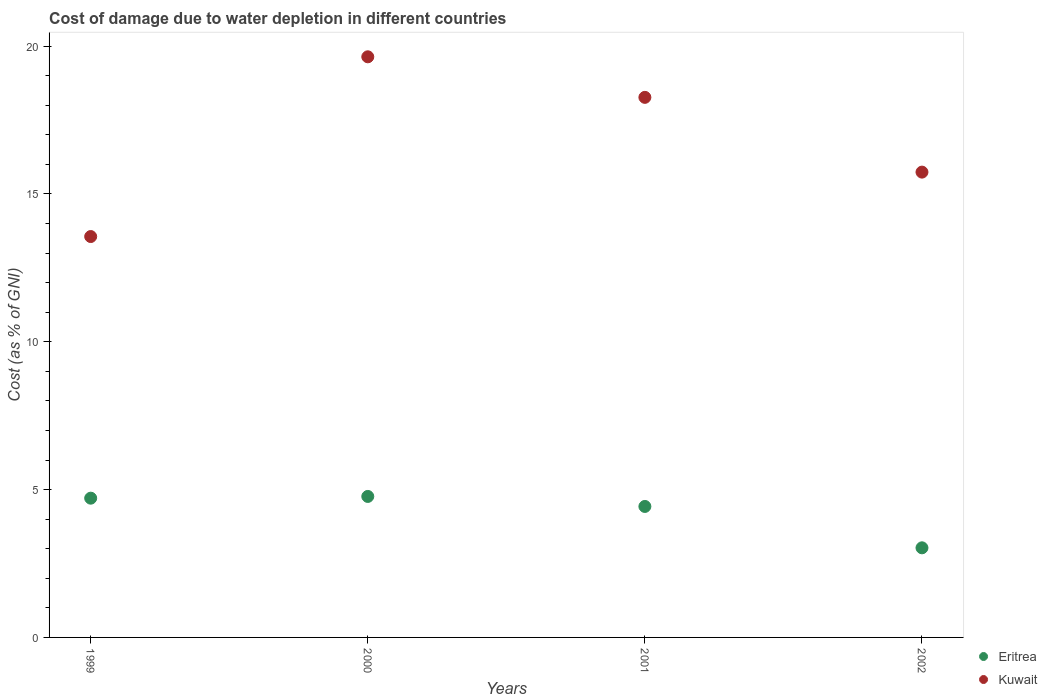What is the cost of damage caused due to water depletion in Eritrea in 2001?
Give a very brief answer. 4.43. Across all years, what is the maximum cost of damage caused due to water depletion in Eritrea?
Offer a very short reply. 4.77. Across all years, what is the minimum cost of damage caused due to water depletion in Kuwait?
Offer a terse response. 13.56. What is the total cost of damage caused due to water depletion in Eritrea in the graph?
Provide a short and direct response. 16.94. What is the difference between the cost of damage caused due to water depletion in Kuwait in 2000 and that in 2001?
Offer a very short reply. 1.37. What is the difference between the cost of damage caused due to water depletion in Kuwait in 2002 and the cost of damage caused due to water depletion in Eritrea in 1999?
Offer a very short reply. 11.03. What is the average cost of damage caused due to water depletion in Eritrea per year?
Keep it short and to the point. 4.23. In the year 2001, what is the difference between the cost of damage caused due to water depletion in Kuwait and cost of damage caused due to water depletion in Eritrea?
Your answer should be compact. 13.83. What is the ratio of the cost of damage caused due to water depletion in Eritrea in 1999 to that in 2001?
Offer a very short reply. 1.06. Is the difference between the cost of damage caused due to water depletion in Kuwait in 1999 and 2001 greater than the difference between the cost of damage caused due to water depletion in Eritrea in 1999 and 2001?
Keep it short and to the point. No. What is the difference between the highest and the second highest cost of damage caused due to water depletion in Kuwait?
Offer a terse response. 1.37. What is the difference between the highest and the lowest cost of damage caused due to water depletion in Eritrea?
Provide a succinct answer. 1.74. In how many years, is the cost of damage caused due to water depletion in Eritrea greater than the average cost of damage caused due to water depletion in Eritrea taken over all years?
Ensure brevity in your answer.  3. Is the sum of the cost of damage caused due to water depletion in Eritrea in 2000 and 2001 greater than the maximum cost of damage caused due to water depletion in Kuwait across all years?
Your answer should be very brief. No. Is the cost of damage caused due to water depletion in Eritrea strictly greater than the cost of damage caused due to water depletion in Kuwait over the years?
Your response must be concise. No. How many dotlines are there?
Give a very brief answer. 2. How many years are there in the graph?
Give a very brief answer. 4. What is the difference between two consecutive major ticks on the Y-axis?
Offer a very short reply. 5. Does the graph contain any zero values?
Ensure brevity in your answer.  No. What is the title of the graph?
Your answer should be very brief. Cost of damage due to water depletion in different countries. Does "Lower middle income" appear as one of the legend labels in the graph?
Provide a short and direct response. No. What is the label or title of the Y-axis?
Your response must be concise. Cost (as % of GNI). What is the Cost (as % of GNI) of Eritrea in 1999?
Keep it short and to the point. 4.71. What is the Cost (as % of GNI) of Kuwait in 1999?
Give a very brief answer. 13.56. What is the Cost (as % of GNI) of Eritrea in 2000?
Your answer should be very brief. 4.77. What is the Cost (as % of GNI) in Kuwait in 2000?
Give a very brief answer. 19.64. What is the Cost (as % of GNI) of Eritrea in 2001?
Your answer should be compact. 4.43. What is the Cost (as % of GNI) in Kuwait in 2001?
Ensure brevity in your answer.  18.26. What is the Cost (as % of GNI) in Eritrea in 2002?
Offer a very short reply. 3.03. What is the Cost (as % of GNI) of Kuwait in 2002?
Give a very brief answer. 15.74. Across all years, what is the maximum Cost (as % of GNI) of Eritrea?
Provide a short and direct response. 4.77. Across all years, what is the maximum Cost (as % of GNI) in Kuwait?
Your response must be concise. 19.64. Across all years, what is the minimum Cost (as % of GNI) of Eritrea?
Your answer should be very brief. 3.03. Across all years, what is the minimum Cost (as % of GNI) in Kuwait?
Your answer should be very brief. 13.56. What is the total Cost (as % of GNI) of Eritrea in the graph?
Give a very brief answer. 16.94. What is the total Cost (as % of GNI) in Kuwait in the graph?
Provide a short and direct response. 67.19. What is the difference between the Cost (as % of GNI) of Eritrea in 1999 and that in 2000?
Your answer should be compact. -0.06. What is the difference between the Cost (as % of GNI) of Kuwait in 1999 and that in 2000?
Offer a terse response. -6.08. What is the difference between the Cost (as % of GNI) in Eritrea in 1999 and that in 2001?
Give a very brief answer. 0.28. What is the difference between the Cost (as % of GNI) in Kuwait in 1999 and that in 2001?
Your answer should be compact. -4.71. What is the difference between the Cost (as % of GNI) of Eritrea in 1999 and that in 2002?
Your answer should be very brief. 1.68. What is the difference between the Cost (as % of GNI) of Kuwait in 1999 and that in 2002?
Your response must be concise. -2.18. What is the difference between the Cost (as % of GNI) of Eritrea in 2000 and that in 2001?
Provide a short and direct response. 0.34. What is the difference between the Cost (as % of GNI) of Kuwait in 2000 and that in 2001?
Offer a terse response. 1.37. What is the difference between the Cost (as % of GNI) of Eritrea in 2000 and that in 2002?
Offer a terse response. 1.74. What is the difference between the Cost (as % of GNI) of Kuwait in 2000 and that in 2002?
Make the answer very short. 3.9. What is the difference between the Cost (as % of GNI) of Eritrea in 2001 and that in 2002?
Your answer should be very brief. 1.4. What is the difference between the Cost (as % of GNI) of Kuwait in 2001 and that in 2002?
Provide a succinct answer. 2.53. What is the difference between the Cost (as % of GNI) of Eritrea in 1999 and the Cost (as % of GNI) of Kuwait in 2000?
Offer a terse response. -14.93. What is the difference between the Cost (as % of GNI) of Eritrea in 1999 and the Cost (as % of GNI) of Kuwait in 2001?
Your answer should be compact. -13.55. What is the difference between the Cost (as % of GNI) of Eritrea in 1999 and the Cost (as % of GNI) of Kuwait in 2002?
Make the answer very short. -11.03. What is the difference between the Cost (as % of GNI) of Eritrea in 2000 and the Cost (as % of GNI) of Kuwait in 2001?
Provide a short and direct response. -13.5. What is the difference between the Cost (as % of GNI) of Eritrea in 2000 and the Cost (as % of GNI) of Kuwait in 2002?
Your answer should be very brief. -10.97. What is the difference between the Cost (as % of GNI) in Eritrea in 2001 and the Cost (as % of GNI) in Kuwait in 2002?
Provide a succinct answer. -11.31. What is the average Cost (as % of GNI) in Eritrea per year?
Provide a succinct answer. 4.23. What is the average Cost (as % of GNI) in Kuwait per year?
Keep it short and to the point. 16.8. In the year 1999, what is the difference between the Cost (as % of GNI) of Eritrea and Cost (as % of GNI) of Kuwait?
Ensure brevity in your answer.  -8.85. In the year 2000, what is the difference between the Cost (as % of GNI) of Eritrea and Cost (as % of GNI) of Kuwait?
Provide a short and direct response. -14.87. In the year 2001, what is the difference between the Cost (as % of GNI) of Eritrea and Cost (as % of GNI) of Kuwait?
Make the answer very short. -13.83. In the year 2002, what is the difference between the Cost (as % of GNI) of Eritrea and Cost (as % of GNI) of Kuwait?
Your answer should be compact. -12.71. What is the ratio of the Cost (as % of GNI) in Eritrea in 1999 to that in 2000?
Keep it short and to the point. 0.99. What is the ratio of the Cost (as % of GNI) of Kuwait in 1999 to that in 2000?
Make the answer very short. 0.69. What is the ratio of the Cost (as % of GNI) in Eritrea in 1999 to that in 2001?
Offer a very short reply. 1.06. What is the ratio of the Cost (as % of GNI) of Kuwait in 1999 to that in 2001?
Provide a short and direct response. 0.74. What is the ratio of the Cost (as % of GNI) of Eritrea in 1999 to that in 2002?
Provide a succinct answer. 1.55. What is the ratio of the Cost (as % of GNI) in Kuwait in 1999 to that in 2002?
Your answer should be compact. 0.86. What is the ratio of the Cost (as % of GNI) of Eritrea in 2000 to that in 2001?
Ensure brevity in your answer.  1.08. What is the ratio of the Cost (as % of GNI) of Kuwait in 2000 to that in 2001?
Keep it short and to the point. 1.08. What is the ratio of the Cost (as % of GNI) of Eritrea in 2000 to that in 2002?
Provide a succinct answer. 1.57. What is the ratio of the Cost (as % of GNI) in Kuwait in 2000 to that in 2002?
Make the answer very short. 1.25. What is the ratio of the Cost (as % of GNI) in Eritrea in 2001 to that in 2002?
Keep it short and to the point. 1.46. What is the ratio of the Cost (as % of GNI) of Kuwait in 2001 to that in 2002?
Offer a terse response. 1.16. What is the difference between the highest and the second highest Cost (as % of GNI) of Eritrea?
Give a very brief answer. 0.06. What is the difference between the highest and the second highest Cost (as % of GNI) of Kuwait?
Give a very brief answer. 1.37. What is the difference between the highest and the lowest Cost (as % of GNI) in Eritrea?
Give a very brief answer. 1.74. What is the difference between the highest and the lowest Cost (as % of GNI) in Kuwait?
Provide a succinct answer. 6.08. 